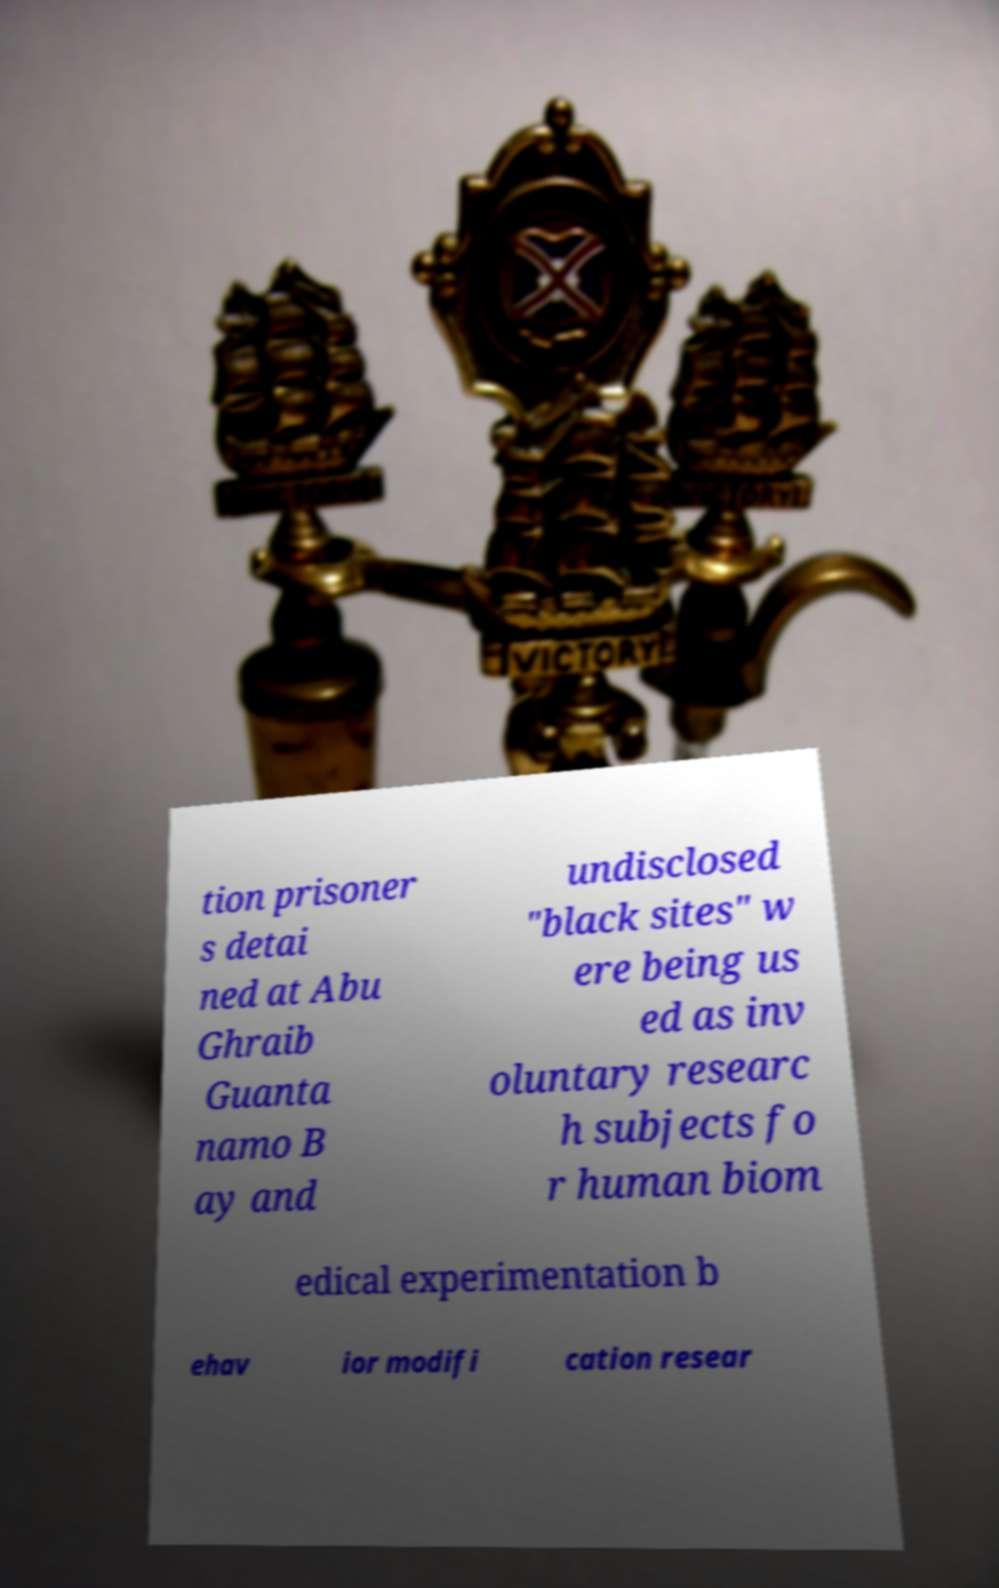Can you accurately transcribe the text from the provided image for me? tion prisoner s detai ned at Abu Ghraib Guanta namo B ay and undisclosed "black sites" w ere being us ed as inv oluntary researc h subjects fo r human biom edical experimentation b ehav ior modifi cation resear 